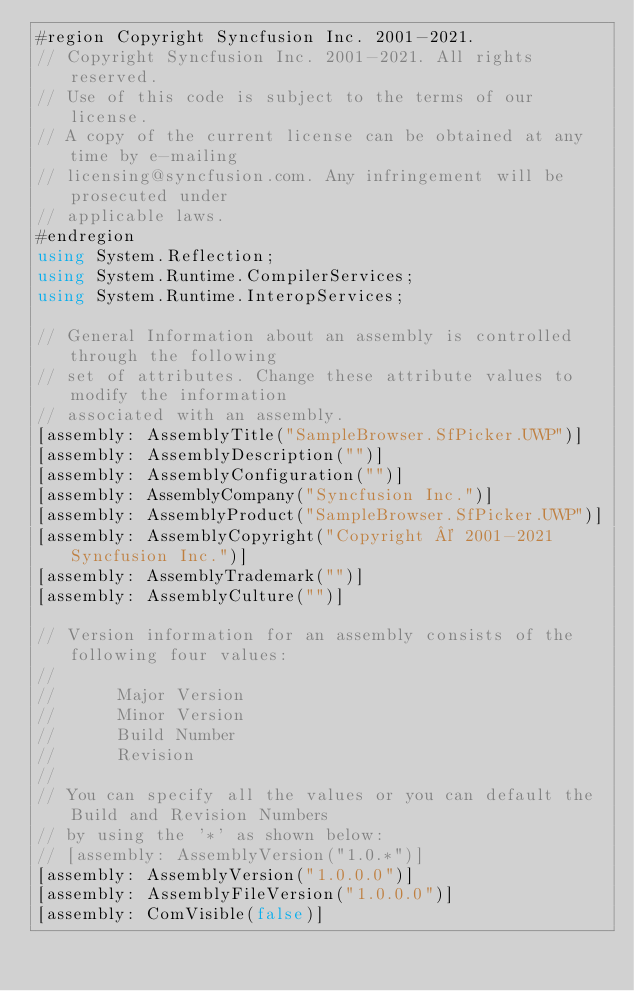Convert code to text. <code><loc_0><loc_0><loc_500><loc_500><_C#_>#region Copyright Syncfusion Inc. 2001-2021.
// Copyright Syncfusion Inc. 2001-2021. All rights reserved.
// Use of this code is subject to the terms of our license.
// A copy of the current license can be obtained at any time by e-mailing
// licensing@syncfusion.com. Any infringement will be prosecuted under
// applicable laws. 
#endregion
using System.Reflection;
using System.Runtime.CompilerServices;
using System.Runtime.InteropServices;

// General Information about an assembly is controlled through the following 
// set of attributes. Change these attribute values to modify the information
// associated with an assembly.
[assembly: AssemblyTitle("SampleBrowser.SfPicker.UWP")]
[assembly: AssemblyDescription("")]
[assembly: AssemblyConfiguration("")]
[assembly: AssemblyCompany("Syncfusion Inc.")]
[assembly: AssemblyProduct("SampleBrowser.SfPicker.UWP")]
[assembly: AssemblyCopyright("Copyright © 2001-2021 Syncfusion Inc.")]
[assembly: AssemblyTrademark("")]
[assembly: AssemblyCulture("")]

// Version information for an assembly consists of the following four values:
//
//      Major Version
//      Minor Version 
//      Build Number
//      Revision
//
// You can specify all the values or you can default the Build and Revision Numbers 
// by using the '*' as shown below:
// [assembly: AssemblyVersion("1.0.*")]
[assembly: AssemblyVersion("1.0.0.0")]
[assembly: AssemblyFileVersion("1.0.0.0")]
[assembly: ComVisible(false)]</code> 